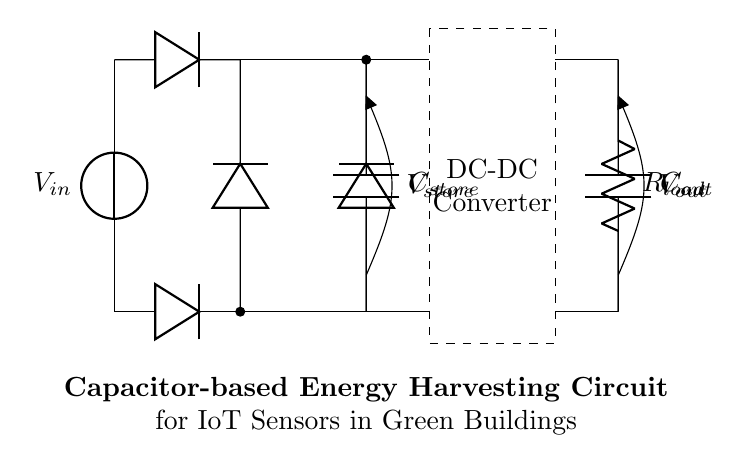What is the function of C_store in this circuit? C_store acts as a storage element for harvested energy, allowing the circuit to accumulate charge for later use. Its main purpose is to store the energy harvested from the input source before it's supplied to the load.
Answer: storage What components are involved in the rectification process? The rectification process in this circuit is achieved with four diodes arranged in a bridge configuration, converting AC to DC, ensuring that the current flows in one direction to charge the capacitor.
Answer: diodes What is the role of R_load in the circuit? R_load represents the load, specifically the IoT sensor that consumes energy from the circuit. Its function is to convert the electrical energy from the output capacitor into usable power for sensor operation.
Answer: load What is the purpose of the DC-DC converter in this circuit? The DC-DC converter adjusts the voltage level from the storage capacitor to the desired output level suitable for the IoT sensor, ensuring efficient power delivery and output regulation.
Answer: voltage regulation What is the relationship between C_out and R_load? C_out acts as a smoothing element providing stable voltage to R_load; it filters voltage fluctuations, while R_load consumes the energy, indicating that they work together to provide consistent power to the IoT sensor.
Answer: smooth operation 